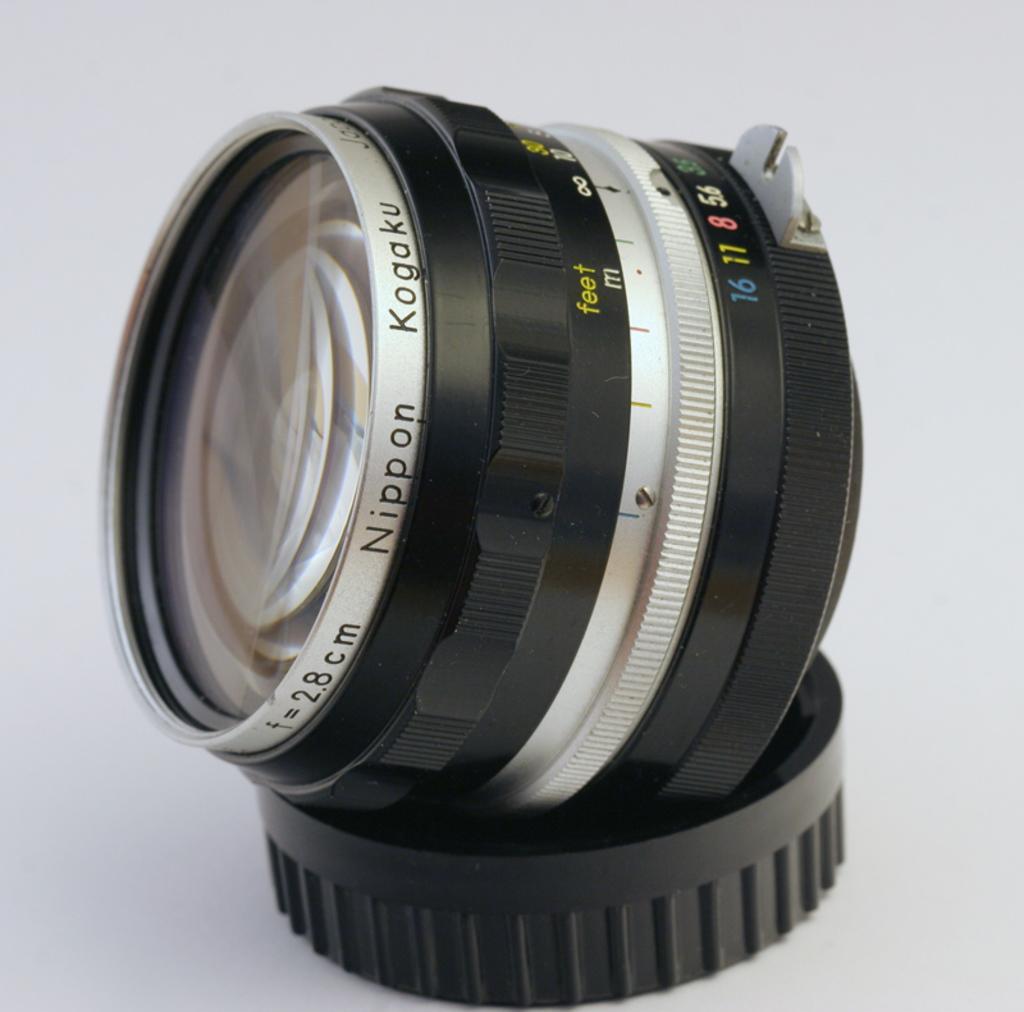How would you summarize this image in a sentence or two? In the picture I can see a camera lens and its lid are placed on the white color surface. 